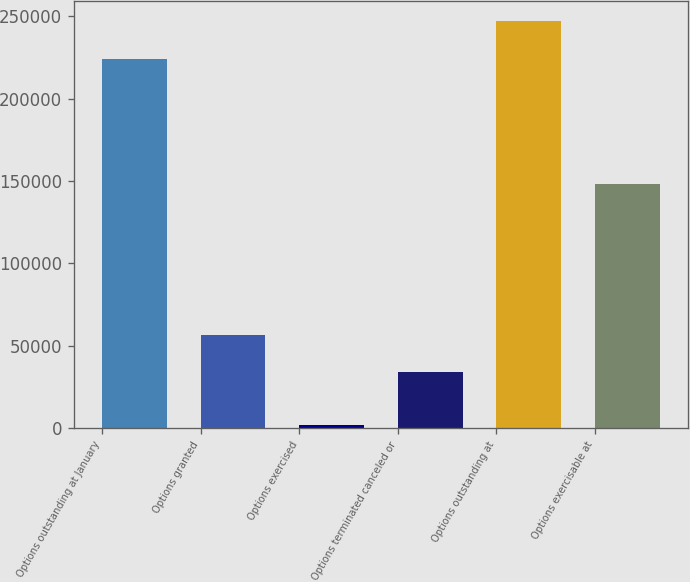Convert chart to OTSL. <chart><loc_0><loc_0><loc_500><loc_500><bar_chart><fcel>Options outstanding at January<fcel>Options granted<fcel>Options exercised<fcel>Options terminated canceled or<fcel>Options outstanding at<fcel>Options exercisable at<nl><fcel>224255<fcel>56576.5<fcel>1920<fcel>33954<fcel>246878<fcel>148072<nl></chart> 